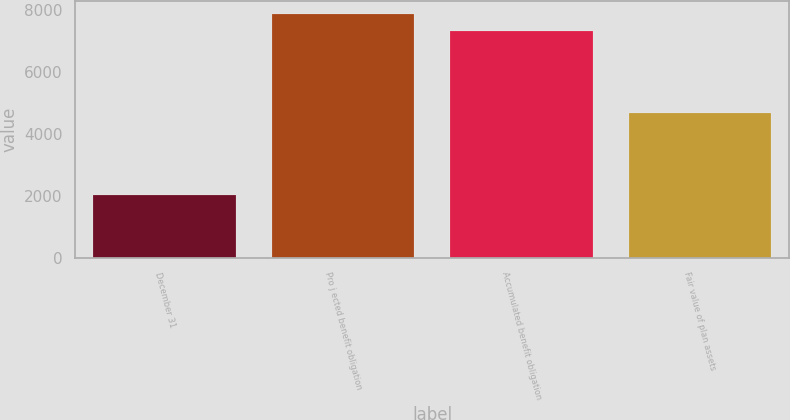Convert chart to OTSL. <chart><loc_0><loc_0><loc_500><loc_500><bar_chart><fcel>December 31<fcel>Pro j ected benefit obligation<fcel>Accumulated benefit obligation<fcel>Fair value of plan assets<nl><fcel>2008<fcel>7869.1<fcel>7312<fcel>4662<nl></chart> 